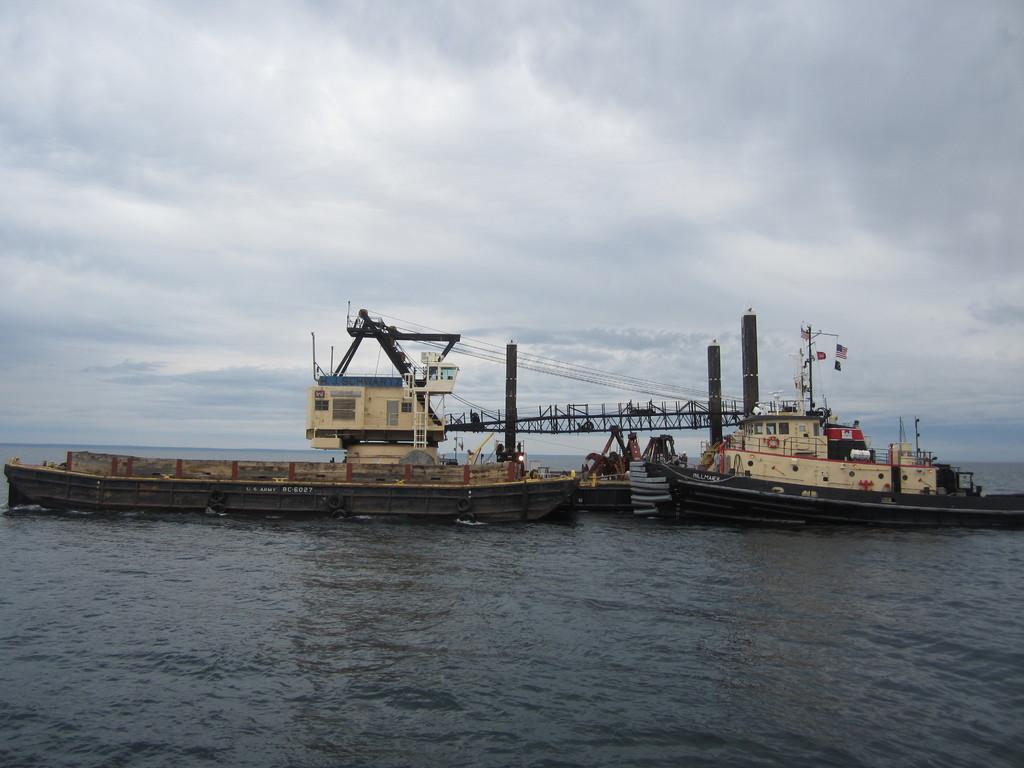Can you describe this image briefly? In this image we can see boats on the water. Here we can see poles, wires, and few objects. In the background there is sky with clouds. 